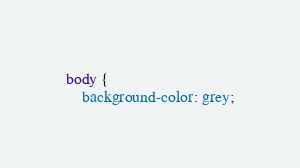<code> <loc_0><loc_0><loc_500><loc_500><_CSS_>body {
    background-color: grey;</code> 